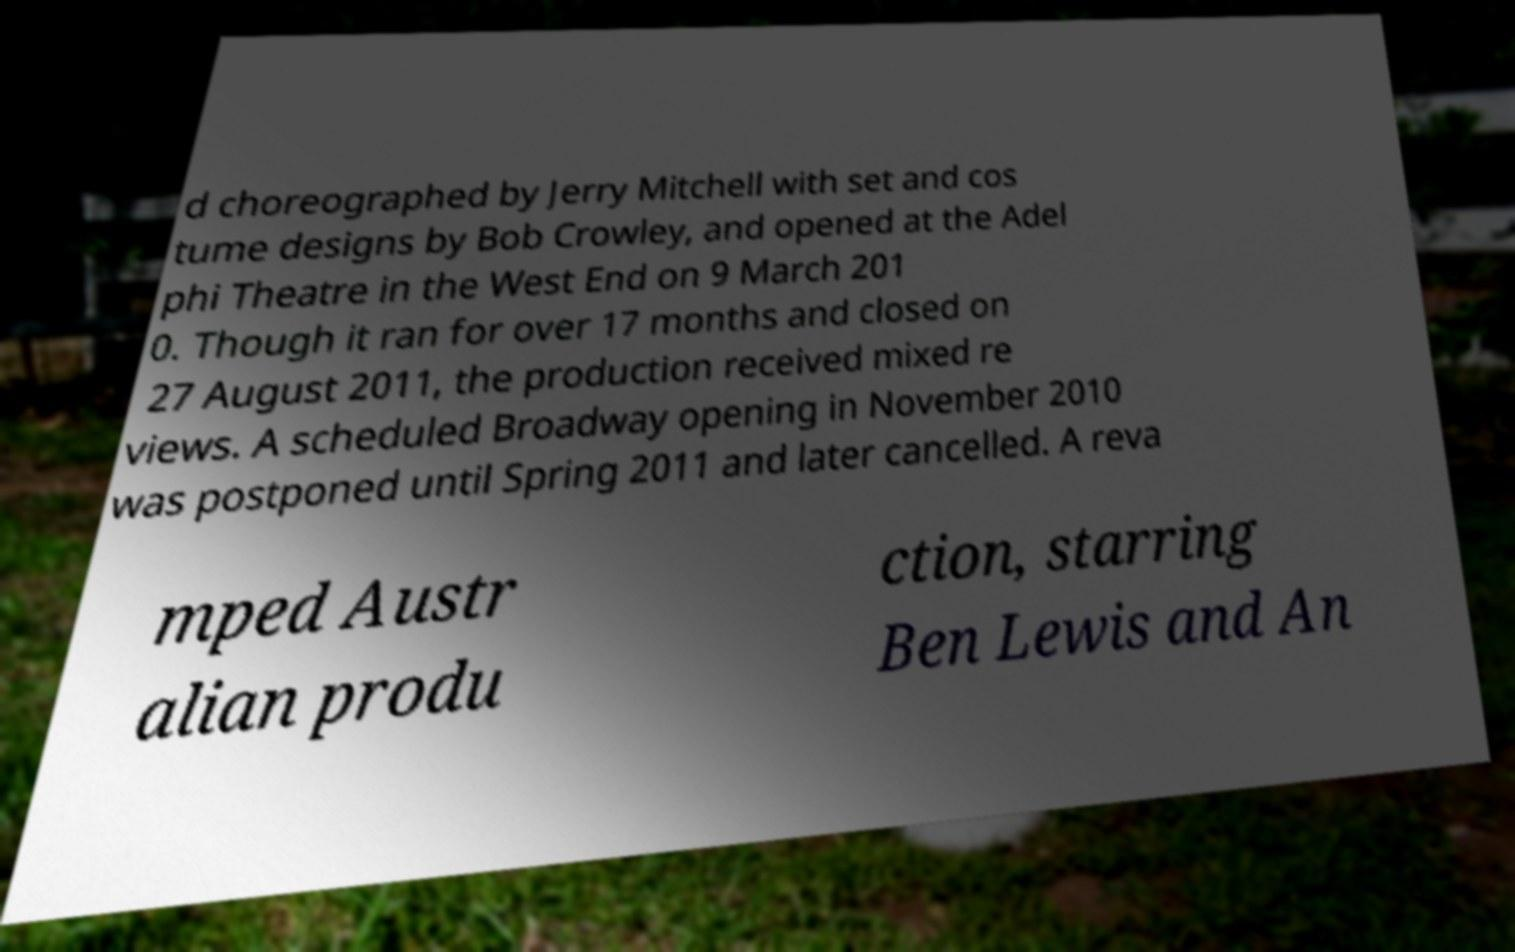Can you accurately transcribe the text from the provided image for me? d choreographed by Jerry Mitchell with set and cos tume designs by Bob Crowley, and opened at the Adel phi Theatre in the West End on 9 March 201 0. Though it ran for over 17 months and closed on 27 August 2011, the production received mixed re views. A scheduled Broadway opening in November 2010 was postponed until Spring 2011 and later cancelled. A reva mped Austr alian produ ction, starring Ben Lewis and An 